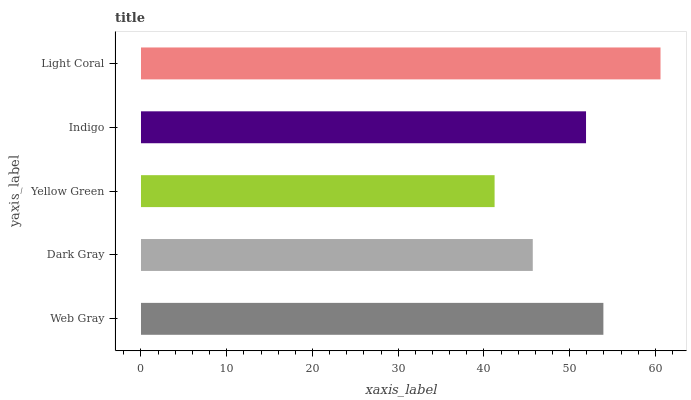Is Yellow Green the minimum?
Answer yes or no. Yes. Is Light Coral the maximum?
Answer yes or no. Yes. Is Dark Gray the minimum?
Answer yes or no. No. Is Dark Gray the maximum?
Answer yes or no. No. Is Web Gray greater than Dark Gray?
Answer yes or no. Yes. Is Dark Gray less than Web Gray?
Answer yes or no. Yes. Is Dark Gray greater than Web Gray?
Answer yes or no. No. Is Web Gray less than Dark Gray?
Answer yes or no. No. Is Indigo the high median?
Answer yes or no. Yes. Is Indigo the low median?
Answer yes or no. Yes. Is Web Gray the high median?
Answer yes or no. No. Is Dark Gray the low median?
Answer yes or no. No. 